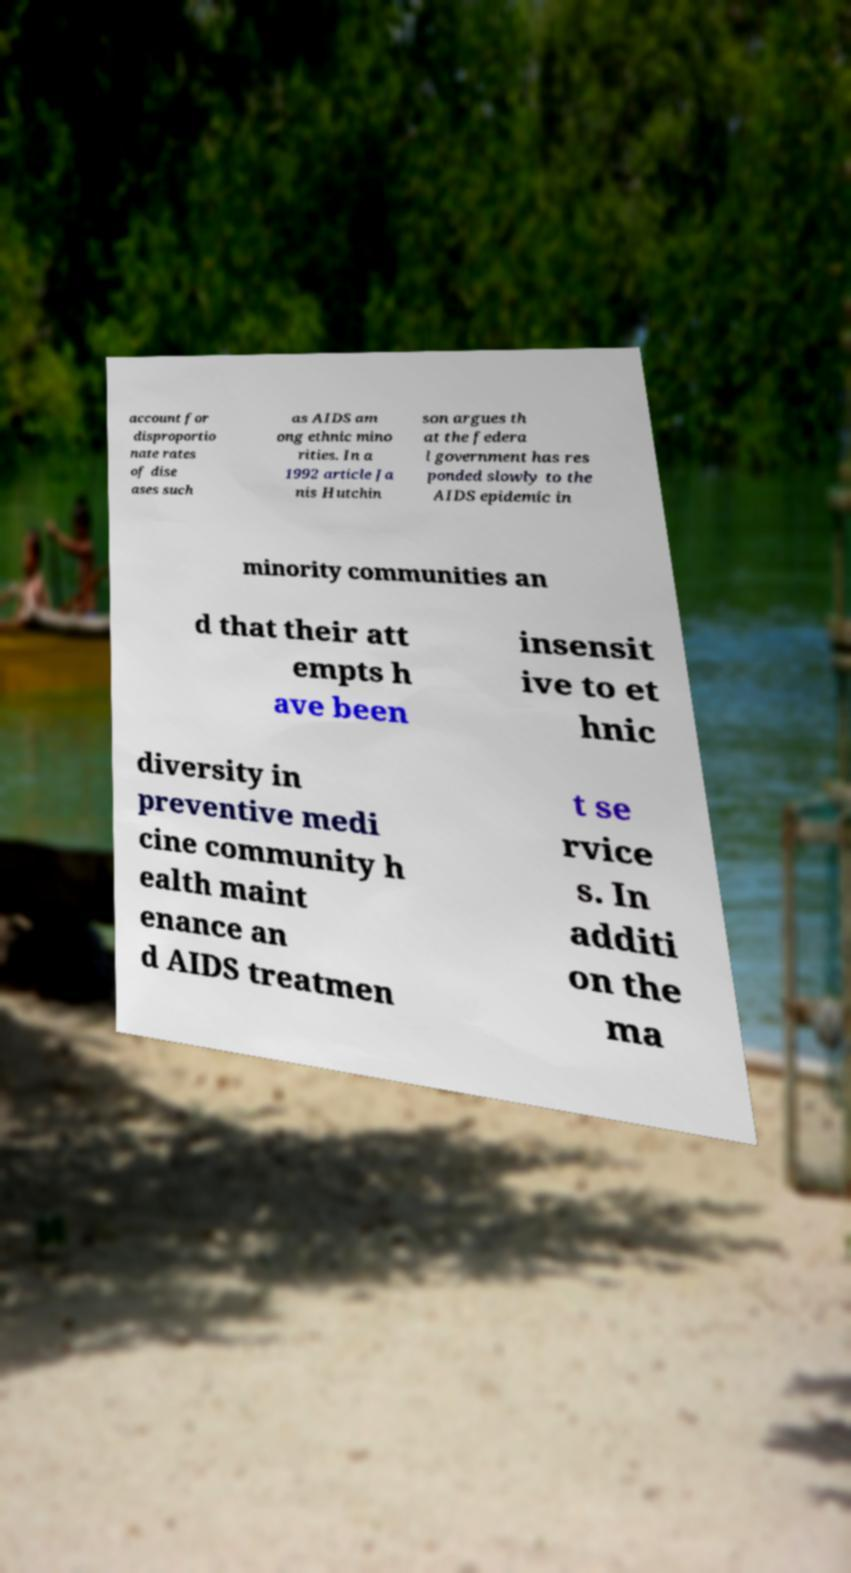There's text embedded in this image that I need extracted. Can you transcribe it verbatim? account for disproportio nate rates of dise ases such as AIDS am ong ethnic mino rities. In a 1992 article Ja nis Hutchin son argues th at the federa l government has res ponded slowly to the AIDS epidemic in minority communities an d that their att empts h ave been insensit ive to et hnic diversity in preventive medi cine community h ealth maint enance an d AIDS treatmen t se rvice s. In additi on the ma 